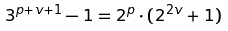<formula> <loc_0><loc_0><loc_500><loc_500>3 ^ { p + v + 1 } - 1 = 2 ^ { p } \cdot ( 2 ^ { 2 v } + 1 )</formula> 